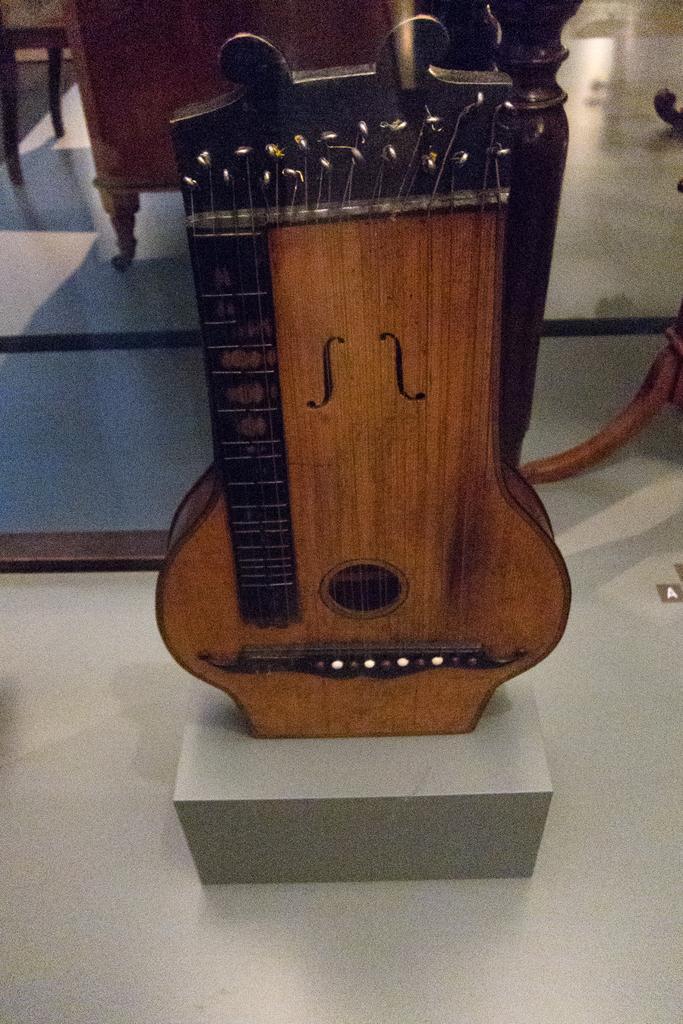How would you summarize this image in a sentence or two? Here I can see a musical instrument which is made up of wood and it is placed on the floor. At the back of it I can see few chairs. 